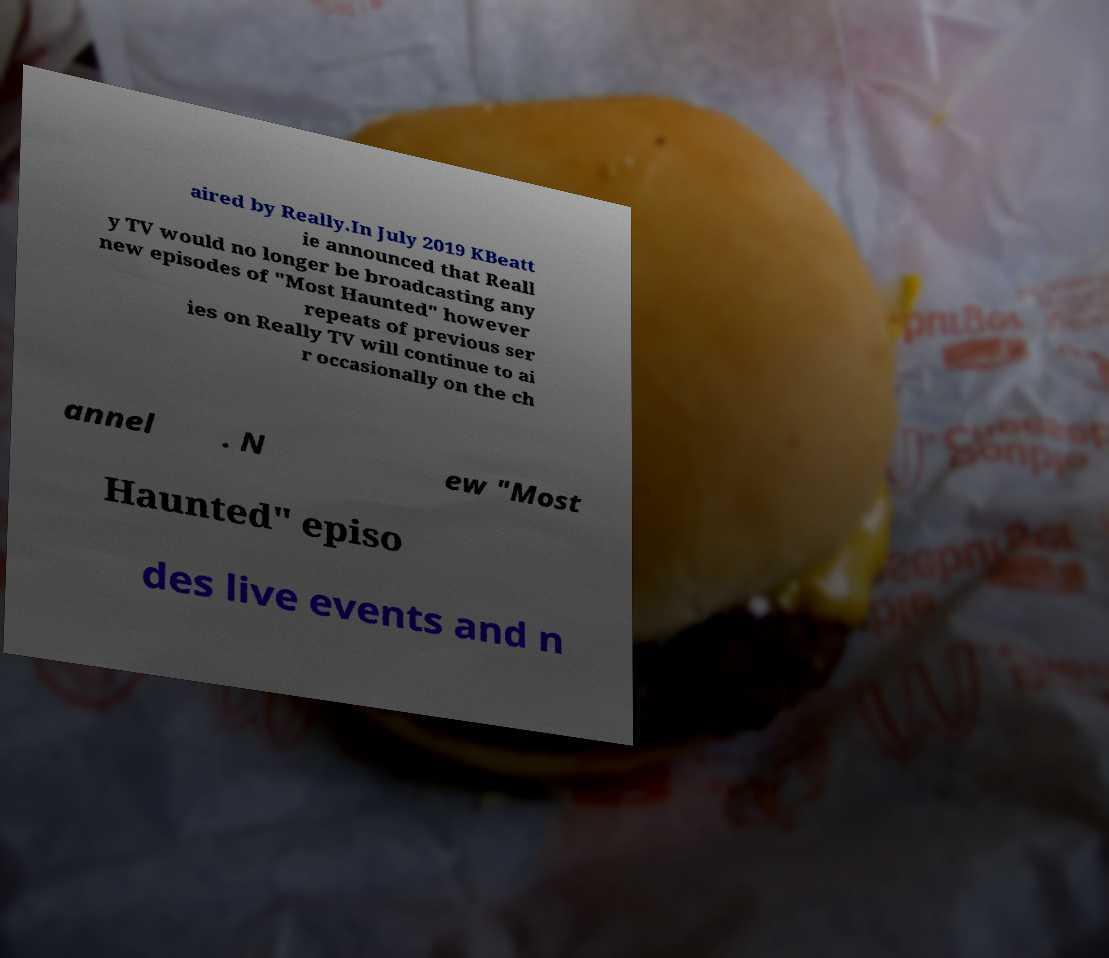Could you extract and type out the text from this image? aired by Really.In July 2019 KBeatt ie announced that Reall y TV would no longer be broadcasting any new episodes of "Most Haunted" however repeats of previous ser ies on Really TV will continue to ai r occasionally on the ch annel . N ew "Most Haunted" episo des live events and n 